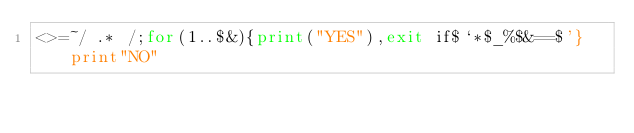<code> <loc_0><loc_0><loc_500><loc_500><_Perl_><>=~/ .* /;for(1..$&){print("YES"),exit if$`*$_%$&==$'}print"NO"</code> 